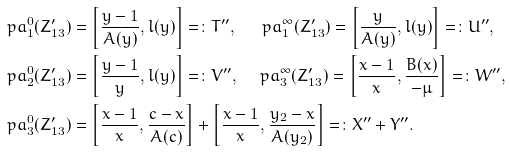Convert formula to latex. <formula><loc_0><loc_0><loc_500><loc_500>\ p a _ { 1 } ^ { 0 } ( Z ^ { \prime } _ { 1 3 } ) & = \left [ \frac { y - 1 } { A ( y ) } , l ( y ) \right ] = \colon T ^ { \prime \prime } , \quad \ \ p a _ { 1 } ^ { \infty } ( Z ^ { \prime } _ { 1 3 } ) = \left [ \frac { y } { A ( y ) } , l ( y ) \right ] = \colon U ^ { \prime \prime } , \\ \ p a _ { 2 } ^ { 0 } ( Z ^ { \prime } _ { 1 3 } ) & = \left [ \frac { y - 1 } { y } , l ( y ) \right ] = \colon V ^ { \prime \prime } , \quad \ p a _ { 3 } ^ { \infty } ( Z ^ { \prime } _ { 1 3 } ) = \left [ \frac { x - 1 } { x } , \frac { B ( x ) } { - \mu } \right ] = \colon W ^ { \prime \prime } , \\ \ p a _ { 3 } ^ { 0 } ( Z ^ { \prime } _ { 1 3 } ) & = \left [ \frac { x - 1 } { x } , \frac { c - x } { A ( c ) } \right ] + \left [ \frac { x - 1 } { x } , \frac { y _ { 2 } - x } { A ( y _ { 2 } ) } \right ] = \colon X ^ { \prime \prime } + Y ^ { \prime \prime } .</formula> 